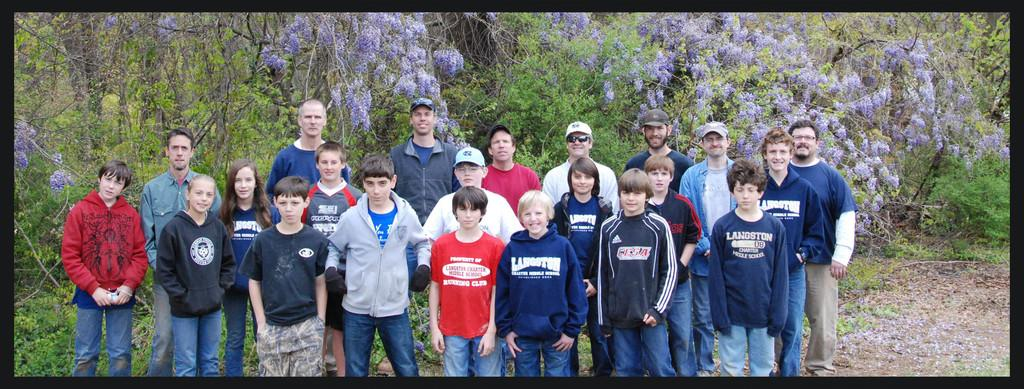What are the people in the image doing? The people in the image are standing on the ground. What can be seen in the background of the image? There are trees, flowers, and grass in the background of the image. How many cherries are hanging from the trees in the image? There are no cherries visible in the image; only trees, flowers, and grass can be seen in the background. 